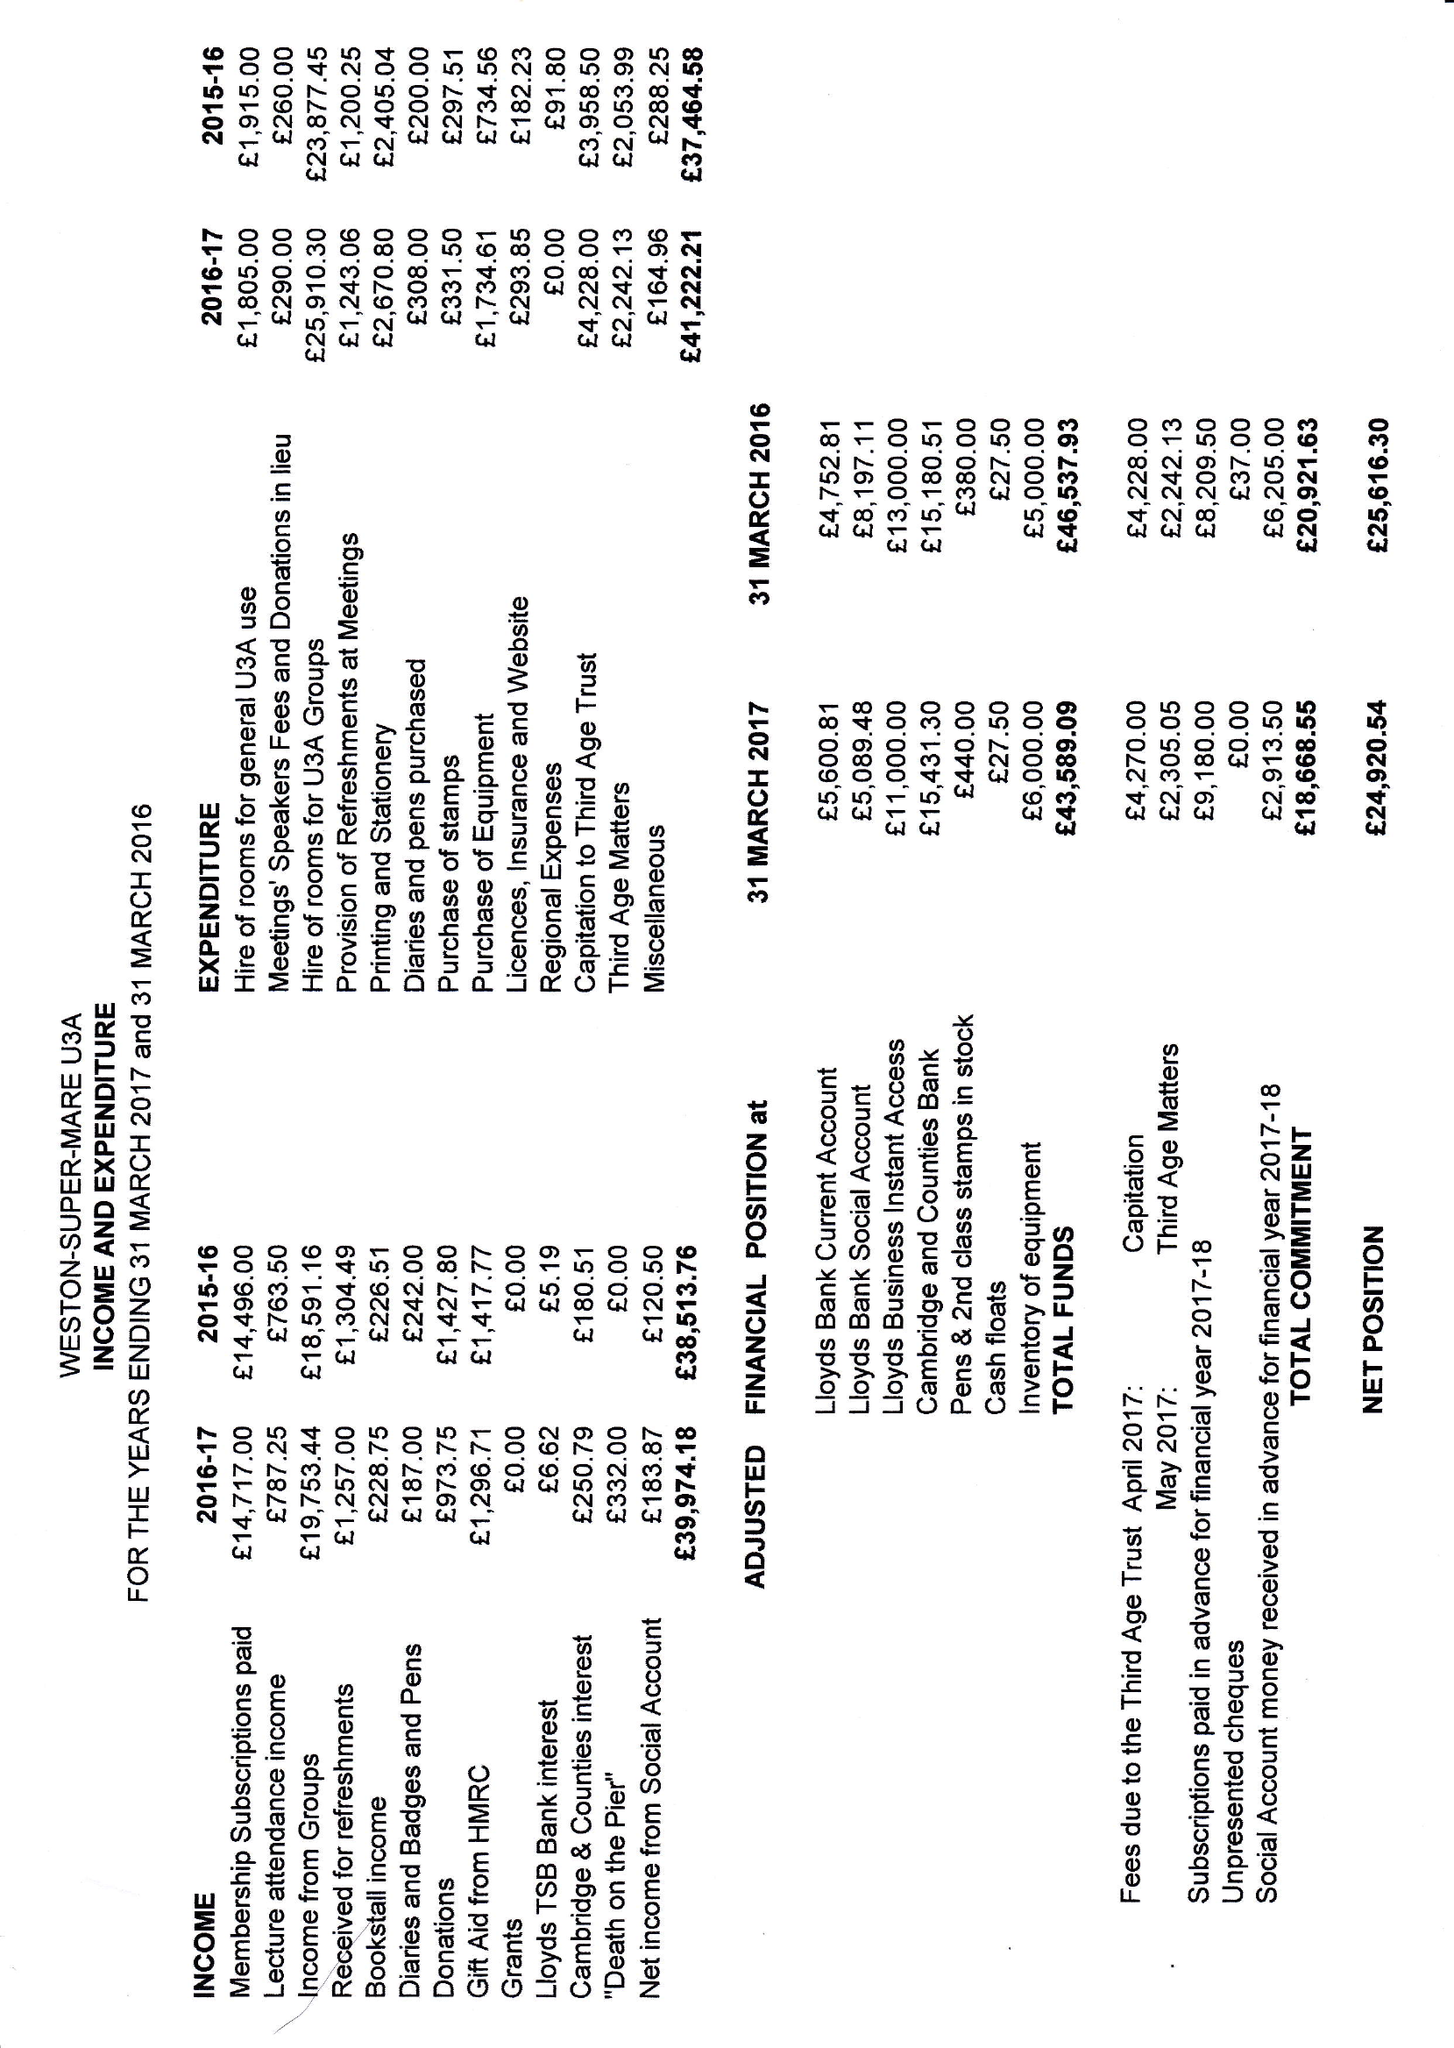What is the value for the charity_number?
Answer the question using a single word or phrase. 1048773 